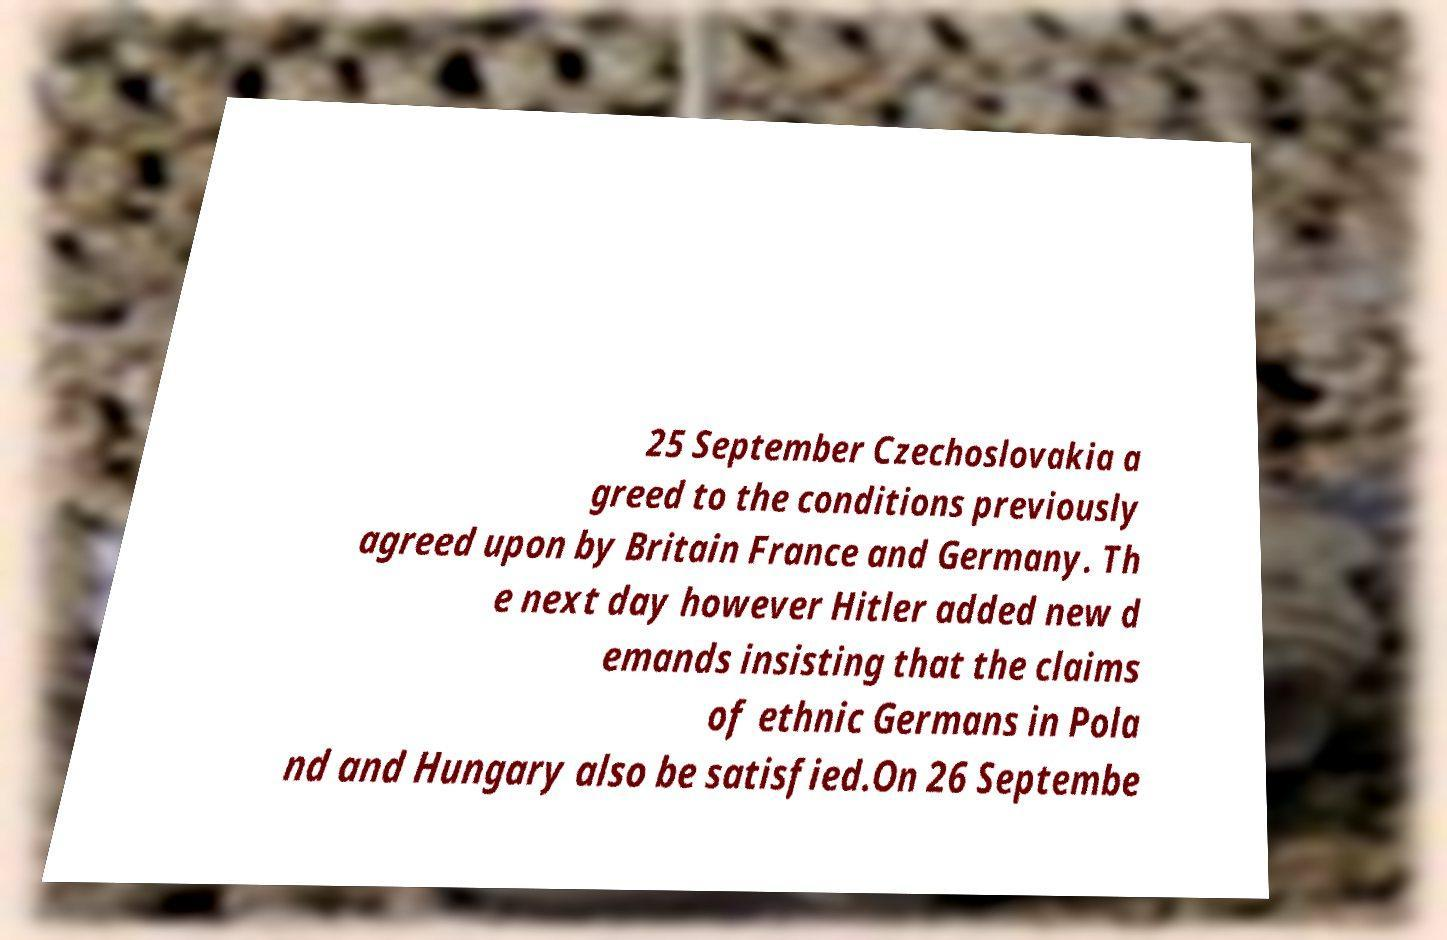I need the written content from this picture converted into text. Can you do that? 25 September Czechoslovakia a greed to the conditions previously agreed upon by Britain France and Germany. Th e next day however Hitler added new d emands insisting that the claims of ethnic Germans in Pola nd and Hungary also be satisfied.On 26 Septembe 